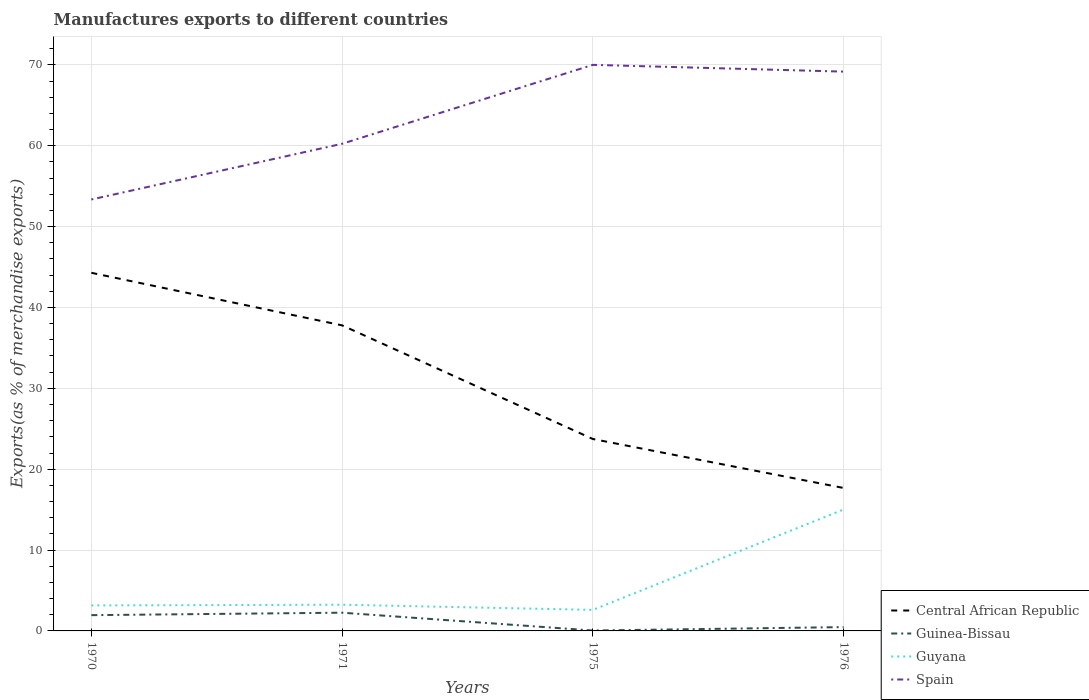How many different coloured lines are there?
Make the answer very short. 4. Does the line corresponding to Guyana intersect with the line corresponding to Central African Republic?
Offer a very short reply. No. Across all years, what is the maximum percentage of exports to different countries in Central African Republic?
Provide a succinct answer. 17.68. In which year was the percentage of exports to different countries in Guinea-Bissau maximum?
Give a very brief answer. 1975. What is the total percentage of exports to different countries in Guyana in the graph?
Provide a short and direct response. -11.86. What is the difference between the highest and the second highest percentage of exports to different countries in Spain?
Provide a succinct answer. 16.65. Are the values on the major ticks of Y-axis written in scientific E-notation?
Keep it short and to the point. No. How are the legend labels stacked?
Offer a very short reply. Vertical. What is the title of the graph?
Your answer should be very brief. Manufactures exports to different countries. What is the label or title of the X-axis?
Your answer should be compact. Years. What is the label or title of the Y-axis?
Give a very brief answer. Exports(as % of merchandise exports). What is the Exports(as % of merchandise exports) of Central African Republic in 1970?
Ensure brevity in your answer.  44.28. What is the Exports(as % of merchandise exports) of Guinea-Bissau in 1970?
Keep it short and to the point. 1.95. What is the Exports(as % of merchandise exports) of Guyana in 1970?
Ensure brevity in your answer.  3.15. What is the Exports(as % of merchandise exports) of Spain in 1970?
Make the answer very short. 53.35. What is the Exports(as % of merchandise exports) in Central African Republic in 1971?
Provide a succinct answer. 37.78. What is the Exports(as % of merchandise exports) of Guinea-Bissau in 1971?
Provide a succinct answer. 2.25. What is the Exports(as % of merchandise exports) in Guyana in 1971?
Offer a very short reply. 3.24. What is the Exports(as % of merchandise exports) of Spain in 1971?
Make the answer very short. 60.24. What is the Exports(as % of merchandise exports) of Central African Republic in 1975?
Your answer should be compact. 23.73. What is the Exports(as % of merchandise exports) of Guinea-Bissau in 1975?
Give a very brief answer. 0.05. What is the Exports(as % of merchandise exports) of Guyana in 1975?
Provide a succinct answer. 2.6. What is the Exports(as % of merchandise exports) of Spain in 1975?
Keep it short and to the point. 70. What is the Exports(as % of merchandise exports) of Central African Republic in 1976?
Your response must be concise. 17.68. What is the Exports(as % of merchandise exports) in Guinea-Bissau in 1976?
Make the answer very short. 0.47. What is the Exports(as % of merchandise exports) of Guyana in 1976?
Give a very brief answer. 15.02. What is the Exports(as % of merchandise exports) in Spain in 1976?
Ensure brevity in your answer.  69.16. Across all years, what is the maximum Exports(as % of merchandise exports) of Central African Republic?
Keep it short and to the point. 44.28. Across all years, what is the maximum Exports(as % of merchandise exports) of Guinea-Bissau?
Keep it short and to the point. 2.25. Across all years, what is the maximum Exports(as % of merchandise exports) of Guyana?
Offer a very short reply. 15.02. Across all years, what is the maximum Exports(as % of merchandise exports) in Spain?
Your response must be concise. 70. Across all years, what is the minimum Exports(as % of merchandise exports) in Central African Republic?
Offer a very short reply. 17.68. Across all years, what is the minimum Exports(as % of merchandise exports) in Guinea-Bissau?
Provide a succinct answer. 0.05. Across all years, what is the minimum Exports(as % of merchandise exports) in Guyana?
Provide a short and direct response. 2.6. Across all years, what is the minimum Exports(as % of merchandise exports) in Spain?
Your response must be concise. 53.35. What is the total Exports(as % of merchandise exports) of Central African Republic in the graph?
Your answer should be very brief. 123.48. What is the total Exports(as % of merchandise exports) of Guinea-Bissau in the graph?
Make the answer very short. 4.73. What is the total Exports(as % of merchandise exports) in Guyana in the graph?
Your answer should be compact. 24.01. What is the total Exports(as % of merchandise exports) in Spain in the graph?
Give a very brief answer. 252.74. What is the difference between the Exports(as % of merchandise exports) in Central African Republic in 1970 and that in 1971?
Provide a short and direct response. 6.5. What is the difference between the Exports(as % of merchandise exports) in Guinea-Bissau in 1970 and that in 1971?
Provide a short and direct response. -0.3. What is the difference between the Exports(as % of merchandise exports) in Guyana in 1970 and that in 1971?
Keep it short and to the point. -0.09. What is the difference between the Exports(as % of merchandise exports) in Spain in 1970 and that in 1971?
Provide a succinct answer. -6.89. What is the difference between the Exports(as % of merchandise exports) in Central African Republic in 1970 and that in 1975?
Make the answer very short. 20.55. What is the difference between the Exports(as % of merchandise exports) in Guinea-Bissau in 1970 and that in 1975?
Provide a succinct answer. 1.9. What is the difference between the Exports(as % of merchandise exports) in Guyana in 1970 and that in 1975?
Your answer should be very brief. 0.55. What is the difference between the Exports(as % of merchandise exports) of Spain in 1970 and that in 1975?
Ensure brevity in your answer.  -16.65. What is the difference between the Exports(as % of merchandise exports) in Central African Republic in 1970 and that in 1976?
Offer a terse response. 26.61. What is the difference between the Exports(as % of merchandise exports) of Guinea-Bissau in 1970 and that in 1976?
Your response must be concise. 1.48. What is the difference between the Exports(as % of merchandise exports) of Guyana in 1970 and that in 1976?
Your response must be concise. -11.86. What is the difference between the Exports(as % of merchandise exports) of Spain in 1970 and that in 1976?
Offer a very short reply. -15.81. What is the difference between the Exports(as % of merchandise exports) of Central African Republic in 1971 and that in 1975?
Your answer should be very brief. 14.05. What is the difference between the Exports(as % of merchandise exports) of Guinea-Bissau in 1971 and that in 1975?
Provide a succinct answer. 2.21. What is the difference between the Exports(as % of merchandise exports) in Guyana in 1971 and that in 1975?
Provide a short and direct response. 0.64. What is the difference between the Exports(as % of merchandise exports) in Spain in 1971 and that in 1975?
Your response must be concise. -9.76. What is the difference between the Exports(as % of merchandise exports) in Central African Republic in 1971 and that in 1976?
Offer a terse response. 20.11. What is the difference between the Exports(as % of merchandise exports) of Guinea-Bissau in 1971 and that in 1976?
Make the answer very short. 1.78. What is the difference between the Exports(as % of merchandise exports) in Guyana in 1971 and that in 1976?
Your answer should be compact. -11.78. What is the difference between the Exports(as % of merchandise exports) of Spain in 1971 and that in 1976?
Keep it short and to the point. -8.92. What is the difference between the Exports(as % of merchandise exports) of Central African Republic in 1975 and that in 1976?
Ensure brevity in your answer.  6.06. What is the difference between the Exports(as % of merchandise exports) of Guinea-Bissau in 1975 and that in 1976?
Offer a terse response. -0.42. What is the difference between the Exports(as % of merchandise exports) of Guyana in 1975 and that in 1976?
Your answer should be compact. -12.42. What is the difference between the Exports(as % of merchandise exports) in Spain in 1975 and that in 1976?
Your response must be concise. 0.84. What is the difference between the Exports(as % of merchandise exports) of Central African Republic in 1970 and the Exports(as % of merchandise exports) of Guinea-Bissau in 1971?
Your answer should be very brief. 42.03. What is the difference between the Exports(as % of merchandise exports) of Central African Republic in 1970 and the Exports(as % of merchandise exports) of Guyana in 1971?
Your answer should be very brief. 41.04. What is the difference between the Exports(as % of merchandise exports) of Central African Republic in 1970 and the Exports(as % of merchandise exports) of Spain in 1971?
Keep it short and to the point. -15.95. What is the difference between the Exports(as % of merchandise exports) in Guinea-Bissau in 1970 and the Exports(as % of merchandise exports) in Guyana in 1971?
Keep it short and to the point. -1.29. What is the difference between the Exports(as % of merchandise exports) of Guinea-Bissau in 1970 and the Exports(as % of merchandise exports) of Spain in 1971?
Keep it short and to the point. -58.29. What is the difference between the Exports(as % of merchandise exports) of Guyana in 1970 and the Exports(as % of merchandise exports) of Spain in 1971?
Offer a terse response. -57.09. What is the difference between the Exports(as % of merchandise exports) in Central African Republic in 1970 and the Exports(as % of merchandise exports) in Guinea-Bissau in 1975?
Give a very brief answer. 44.23. What is the difference between the Exports(as % of merchandise exports) of Central African Republic in 1970 and the Exports(as % of merchandise exports) of Guyana in 1975?
Ensure brevity in your answer.  41.68. What is the difference between the Exports(as % of merchandise exports) in Central African Republic in 1970 and the Exports(as % of merchandise exports) in Spain in 1975?
Your response must be concise. -25.71. What is the difference between the Exports(as % of merchandise exports) in Guinea-Bissau in 1970 and the Exports(as % of merchandise exports) in Guyana in 1975?
Make the answer very short. -0.65. What is the difference between the Exports(as % of merchandise exports) in Guinea-Bissau in 1970 and the Exports(as % of merchandise exports) in Spain in 1975?
Give a very brief answer. -68.05. What is the difference between the Exports(as % of merchandise exports) in Guyana in 1970 and the Exports(as % of merchandise exports) in Spain in 1975?
Your answer should be very brief. -66.85. What is the difference between the Exports(as % of merchandise exports) of Central African Republic in 1970 and the Exports(as % of merchandise exports) of Guinea-Bissau in 1976?
Make the answer very short. 43.81. What is the difference between the Exports(as % of merchandise exports) of Central African Republic in 1970 and the Exports(as % of merchandise exports) of Guyana in 1976?
Offer a terse response. 29.27. What is the difference between the Exports(as % of merchandise exports) in Central African Republic in 1970 and the Exports(as % of merchandise exports) in Spain in 1976?
Give a very brief answer. -24.88. What is the difference between the Exports(as % of merchandise exports) of Guinea-Bissau in 1970 and the Exports(as % of merchandise exports) of Guyana in 1976?
Make the answer very short. -13.07. What is the difference between the Exports(as % of merchandise exports) in Guinea-Bissau in 1970 and the Exports(as % of merchandise exports) in Spain in 1976?
Make the answer very short. -67.21. What is the difference between the Exports(as % of merchandise exports) of Guyana in 1970 and the Exports(as % of merchandise exports) of Spain in 1976?
Ensure brevity in your answer.  -66.01. What is the difference between the Exports(as % of merchandise exports) of Central African Republic in 1971 and the Exports(as % of merchandise exports) of Guinea-Bissau in 1975?
Your answer should be compact. 37.74. What is the difference between the Exports(as % of merchandise exports) in Central African Republic in 1971 and the Exports(as % of merchandise exports) in Guyana in 1975?
Offer a terse response. 35.18. What is the difference between the Exports(as % of merchandise exports) of Central African Republic in 1971 and the Exports(as % of merchandise exports) of Spain in 1975?
Offer a very short reply. -32.21. What is the difference between the Exports(as % of merchandise exports) in Guinea-Bissau in 1971 and the Exports(as % of merchandise exports) in Guyana in 1975?
Offer a very short reply. -0.35. What is the difference between the Exports(as % of merchandise exports) of Guinea-Bissau in 1971 and the Exports(as % of merchandise exports) of Spain in 1975?
Keep it short and to the point. -67.74. What is the difference between the Exports(as % of merchandise exports) of Guyana in 1971 and the Exports(as % of merchandise exports) of Spain in 1975?
Make the answer very short. -66.76. What is the difference between the Exports(as % of merchandise exports) in Central African Republic in 1971 and the Exports(as % of merchandise exports) in Guinea-Bissau in 1976?
Keep it short and to the point. 37.31. What is the difference between the Exports(as % of merchandise exports) in Central African Republic in 1971 and the Exports(as % of merchandise exports) in Guyana in 1976?
Provide a short and direct response. 22.77. What is the difference between the Exports(as % of merchandise exports) in Central African Republic in 1971 and the Exports(as % of merchandise exports) in Spain in 1976?
Ensure brevity in your answer.  -31.38. What is the difference between the Exports(as % of merchandise exports) of Guinea-Bissau in 1971 and the Exports(as % of merchandise exports) of Guyana in 1976?
Ensure brevity in your answer.  -12.76. What is the difference between the Exports(as % of merchandise exports) of Guinea-Bissau in 1971 and the Exports(as % of merchandise exports) of Spain in 1976?
Your answer should be very brief. -66.91. What is the difference between the Exports(as % of merchandise exports) of Guyana in 1971 and the Exports(as % of merchandise exports) of Spain in 1976?
Provide a succinct answer. -65.92. What is the difference between the Exports(as % of merchandise exports) of Central African Republic in 1975 and the Exports(as % of merchandise exports) of Guinea-Bissau in 1976?
Offer a very short reply. 23.26. What is the difference between the Exports(as % of merchandise exports) in Central African Republic in 1975 and the Exports(as % of merchandise exports) in Guyana in 1976?
Make the answer very short. 8.72. What is the difference between the Exports(as % of merchandise exports) of Central African Republic in 1975 and the Exports(as % of merchandise exports) of Spain in 1976?
Ensure brevity in your answer.  -45.43. What is the difference between the Exports(as % of merchandise exports) of Guinea-Bissau in 1975 and the Exports(as % of merchandise exports) of Guyana in 1976?
Your answer should be very brief. -14.97. What is the difference between the Exports(as % of merchandise exports) of Guinea-Bissau in 1975 and the Exports(as % of merchandise exports) of Spain in 1976?
Provide a succinct answer. -69.11. What is the difference between the Exports(as % of merchandise exports) of Guyana in 1975 and the Exports(as % of merchandise exports) of Spain in 1976?
Your answer should be very brief. -66.56. What is the average Exports(as % of merchandise exports) in Central African Republic per year?
Provide a succinct answer. 30.87. What is the average Exports(as % of merchandise exports) of Guinea-Bissau per year?
Make the answer very short. 1.18. What is the average Exports(as % of merchandise exports) of Guyana per year?
Ensure brevity in your answer.  6. What is the average Exports(as % of merchandise exports) of Spain per year?
Your answer should be compact. 63.19. In the year 1970, what is the difference between the Exports(as % of merchandise exports) in Central African Republic and Exports(as % of merchandise exports) in Guinea-Bissau?
Give a very brief answer. 42.33. In the year 1970, what is the difference between the Exports(as % of merchandise exports) of Central African Republic and Exports(as % of merchandise exports) of Guyana?
Offer a terse response. 41.13. In the year 1970, what is the difference between the Exports(as % of merchandise exports) of Central African Republic and Exports(as % of merchandise exports) of Spain?
Offer a very short reply. -9.07. In the year 1970, what is the difference between the Exports(as % of merchandise exports) of Guinea-Bissau and Exports(as % of merchandise exports) of Guyana?
Provide a succinct answer. -1.2. In the year 1970, what is the difference between the Exports(as % of merchandise exports) of Guinea-Bissau and Exports(as % of merchandise exports) of Spain?
Offer a very short reply. -51.4. In the year 1970, what is the difference between the Exports(as % of merchandise exports) in Guyana and Exports(as % of merchandise exports) in Spain?
Keep it short and to the point. -50.2. In the year 1971, what is the difference between the Exports(as % of merchandise exports) in Central African Republic and Exports(as % of merchandise exports) in Guinea-Bissau?
Your answer should be compact. 35.53. In the year 1971, what is the difference between the Exports(as % of merchandise exports) of Central African Republic and Exports(as % of merchandise exports) of Guyana?
Provide a succinct answer. 34.54. In the year 1971, what is the difference between the Exports(as % of merchandise exports) of Central African Republic and Exports(as % of merchandise exports) of Spain?
Provide a succinct answer. -22.45. In the year 1971, what is the difference between the Exports(as % of merchandise exports) in Guinea-Bissau and Exports(as % of merchandise exports) in Guyana?
Provide a succinct answer. -0.99. In the year 1971, what is the difference between the Exports(as % of merchandise exports) in Guinea-Bissau and Exports(as % of merchandise exports) in Spain?
Ensure brevity in your answer.  -57.98. In the year 1971, what is the difference between the Exports(as % of merchandise exports) of Guyana and Exports(as % of merchandise exports) of Spain?
Ensure brevity in your answer.  -57. In the year 1975, what is the difference between the Exports(as % of merchandise exports) of Central African Republic and Exports(as % of merchandise exports) of Guinea-Bissau?
Provide a short and direct response. 23.68. In the year 1975, what is the difference between the Exports(as % of merchandise exports) in Central African Republic and Exports(as % of merchandise exports) in Guyana?
Give a very brief answer. 21.13. In the year 1975, what is the difference between the Exports(as % of merchandise exports) in Central African Republic and Exports(as % of merchandise exports) in Spain?
Ensure brevity in your answer.  -46.26. In the year 1975, what is the difference between the Exports(as % of merchandise exports) of Guinea-Bissau and Exports(as % of merchandise exports) of Guyana?
Your answer should be compact. -2.55. In the year 1975, what is the difference between the Exports(as % of merchandise exports) of Guinea-Bissau and Exports(as % of merchandise exports) of Spain?
Make the answer very short. -69.95. In the year 1975, what is the difference between the Exports(as % of merchandise exports) in Guyana and Exports(as % of merchandise exports) in Spain?
Give a very brief answer. -67.4. In the year 1976, what is the difference between the Exports(as % of merchandise exports) in Central African Republic and Exports(as % of merchandise exports) in Guinea-Bissau?
Your answer should be compact. 17.2. In the year 1976, what is the difference between the Exports(as % of merchandise exports) in Central African Republic and Exports(as % of merchandise exports) in Guyana?
Provide a succinct answer. 2.66. In the year 1976, what is the difference between the Exports(as % of merchandise exports) in Central African Republic and Exports(as % of merchandise exports) in Spain?
Make the answer very short. -51.49. In the year 1976, what is the difference between the Exports(as % of merchandise exports) in Guinea-Bissau and Exports(as % of merchandise exports) in Guyana?
Your response must be concise. -14.54. In the year 1976, what is the difference between the Exports(as % of merchandise exports) in Guinea-Bissau and Exports(as % of merchandise exports) in Spain?
Ensure brevity in your answer.  -68.69. In the year 1976, what is the difference between the Exports(as % of merchandise exports) in Guyana and Exports(as % of merchandise exports) in Spain?
Ensure brevity in your answer.  -54.15. What is the ratio of the Exports(as % of merchandise exports) of Central African Republic in 1970 to that in 1971?
Make the answer very short. 1.17. What is the ratio of the Exports(as % of merchandise exports) of Guinea-Bissau in 1970 to that in 1971?
Make the answer very short. 0.87. What is the ratio of the Exports(as % of merchandise exports) of Guyana in 1970 to that in 1971?
Offer a terse response. 0.97. What is the ratio of the Exports(as % of merchandise exports) in Spain in 1970 to that in 1971?
Your answer should be compact. 0.89. What is the ratio of the Exports(as % of merchandise exports) of Central African Republic in 1970 to that in 1975?
Your answer should be very brief. 1.87. What is the ratio of the Exports(as % of merchandise exports) of Guinea-Bissau in 1970 to that in 1975?
Make the answer very short. 39.71. What is the ratio of the Exports(as % of merchandise exports) in Guyana in 1970 to that in 1975?
Ensure brevity in your answer.  1.21. What is the ratio of the Exports(as % of merchandise exports) in Spain in 1970 to that in 1975?
Your response must be concise. 0.76. What is the ratio of the Exports(as % of merchandise exports) of Central African Republic in 1970 to that in 1976?
Provide a succinct answer. 2.51. What is the ratio of the Exports(as % of merchandise exports) of Guinea-Bissau in 1970 to that in 1976?
Your answer should be compact. 4.12. What is the ratio of the Exports(as % of merchandise exports) of Guyana in 1970 to that in 1976?
Your response must be concise. 0.21. What is the ratio of the Exports(as % of merchandise exports) of Spain in 1970 to that in 1976?
Give a very brief answer. 0.77. What is the ratio of the Exports(as % of merchandise exports) in Central African Republic in 1971 to that in 1975?
Keep it short and to the point. 1.59. What is the ratio of the Exports(as % of merchandise exports) in Guinea-Bissau in 1971 to that in 1975?
Your response must be concise. 45.91. What is the ratio of the Exports(as % of merchandise exports) of Guyana in 1971 to that in 1975?
Your answer should be very brief. 1.25. What is the ratio of the Exports(as % of merchandise exports) of Spain in 1971 to that in 1975?
Offer a very short reply. 0.86. What is the ratio of the Exports(as % of merchandise exports) of Central African Republic in 1971 to that in 1976?
Give a very brief answer. 2.14. What is the ratio of the Exports(as % of merchandise exports) in Guinea-Bissau in 1971 to that in 1976?
Make the answer very short. 4.76. What is the ratio of the Exports(as % of merchandise exports) of Guyana in 1971 to that in 1976?
Your answer should be compact. 0.22. What is the ratio of the Exports(as % of merchandise exports) in Spain in 1971 to that in 1976?
Keep it short and to the point. 0.87. What is the ratio of the Exports(as % of merchandise exports) in Central African Republic in 1975 to that in 1976?
Provide a short and direct response. 1.34. What is the ratio of the Exports(as % of merchandise exports) of Guinea-Bissau in 1975 to that in 1976?
Provide a short and direct response. 0.1. What is the ratio of the Exports(as % of merchandise exports) in Guyana in 1975 to that in 1976?
Ensure brevity in your answer.  0.17. What is the ratio of the Exports(as % of merchandise exports) in Spain in 1975 to that in 1976?
Keep it short and to the point. 1.01. What is the difference between the highest and the second highest Exports(as % of merchandise exports) in Central African Republic?
Offer a terse response. 6.5. What is the difference between the highest and the second highest Exports(as % of merchandise exports) in Guinea-Bissau?
Provide a succinct answer. 0.3. What is the difference between the highest and the second highest Exports(as % of merchandise exports) of Guyana?
Give a very brief answer. 11.78. What is the difference between the highest and the second highest Exports(as % of merchandise exports) of Spain?
Ensure brevity in your answer.  0.84. What is the difference between the highest and the lowest Exports(as % of merchandise exports) of Central African Republic?
Ensure brevity in your answer.  26.61. What is the difference between the highest and the lowest Exports(as % of merchandise exports) in Guinea-Bissau?
Give a very brief answer. 2.21. What is the difference between the highest and the lowest Exports(as % of merchandise exports) in Guyana?
Make the answer very short. 12.42. What is the difference between the highest and the lowest Exports(as % of merchandise exports) in Spain?
Ensure brevity in your answer.  16.65. 